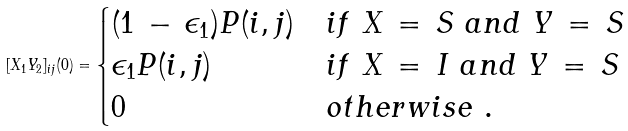Convert formula to latex. <formula><loc_0><loc_0><loc_500><loc_500>[ X _ { 1 } Y _ { 2 } ] _ { i j } ( 0 ) = \begin{cases} ( 1 \, - \, \epsilon _ { 1 } ) P ( i , j ) & i f \ X \, = \, S \ a n d \ Y \, = \, S \\ \epsilon _ { 1 } P ( i , j ) & i f \ X \, = \, I \ a n d \ Y \, = \, S \\ 0 & o t h e r w i s e \ . \end{cases}</formula> 